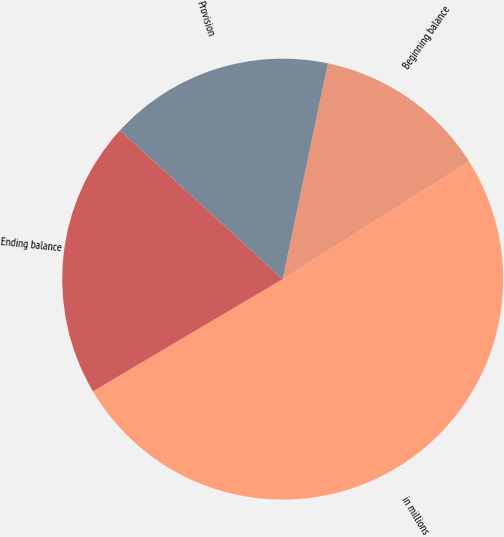Convert chart to OTSL. <chart><loc_0><loc_0><loc_500><loc_500><pie_chart><fcel>in millions<fcel>Beginning balance<fcel>Provision<fcel>Ending balance<nl><fcel>50.47%<fcel>12.74%<fcel>16.51%<fcel>20.28%<nl></chart> 